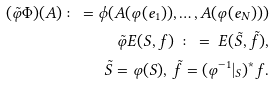Convert formula to latex. <formula><loc_0><loc_0><loc_500><loc_500>( \tilde { \varphi } \Phi ) ( A ) \colon = \phi ( A ( \varphi ( e _ { 1 } ) ) , \dots , A ( \varphi ( e _ { N } ) ) ) \\ \tilde { \varphi } E ( S , f ) \ \colon = \ E ( \tilde { S } , \tilde { f } ) , \\ \tilde { S } = \varphi ( S ) , \, \tilde { f } = ( \varphi ^ { - 1 } | _ { S } ) ^ { \ast } f .</formula> 